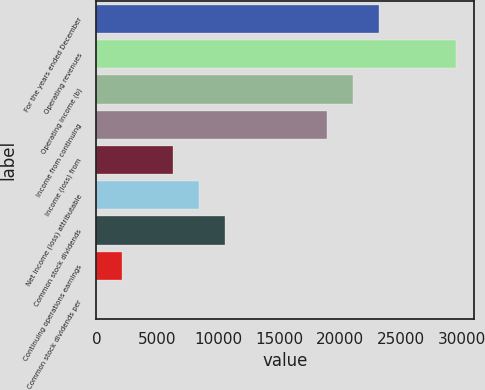Convert chart. <chart><loc_0><loc_0><loc_500><loc_500><bar_chart><fcel>For the years ended December<fcel>Operating revenues<fcel>Operating income (b)<fcel>Income from continuing<fcel>Income (loss) from<fcel>Net income (loss) attributable<fcel>Common stock dividends<fcel>Continuing operations earnings<fcel>Common stock dividends per<nl><fcel>23146<fcel>29458.2<fcel>21042<fcel>18938<fcel>6313.72<fcel>8417.76<fcel>10521.8<fcel>2105.64<fcel>1.6<nl></chart> 